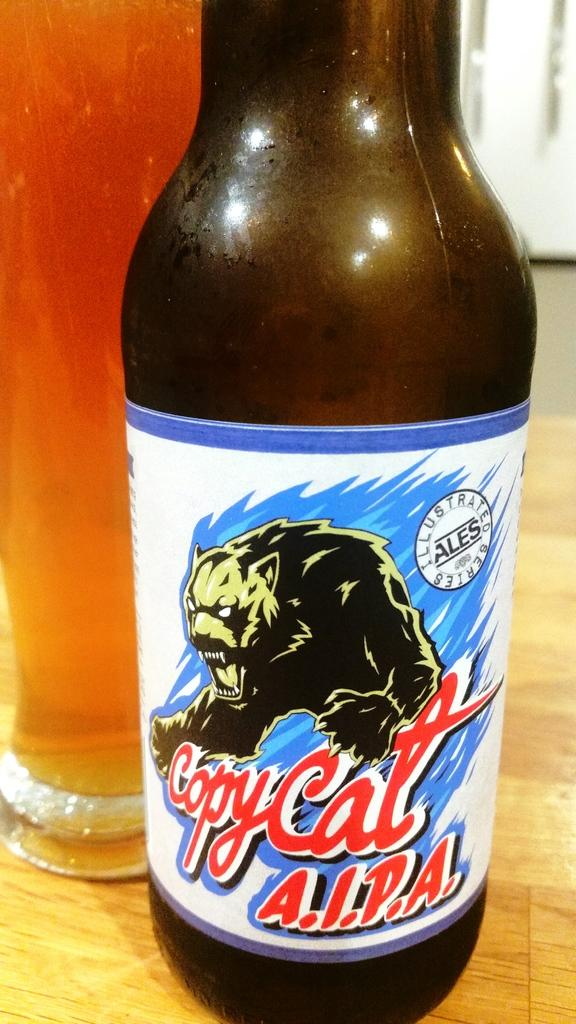<image>
Write a terse but informative summary of the picture. A beer label for Copy Cat A.I.P.A. features a panther. 